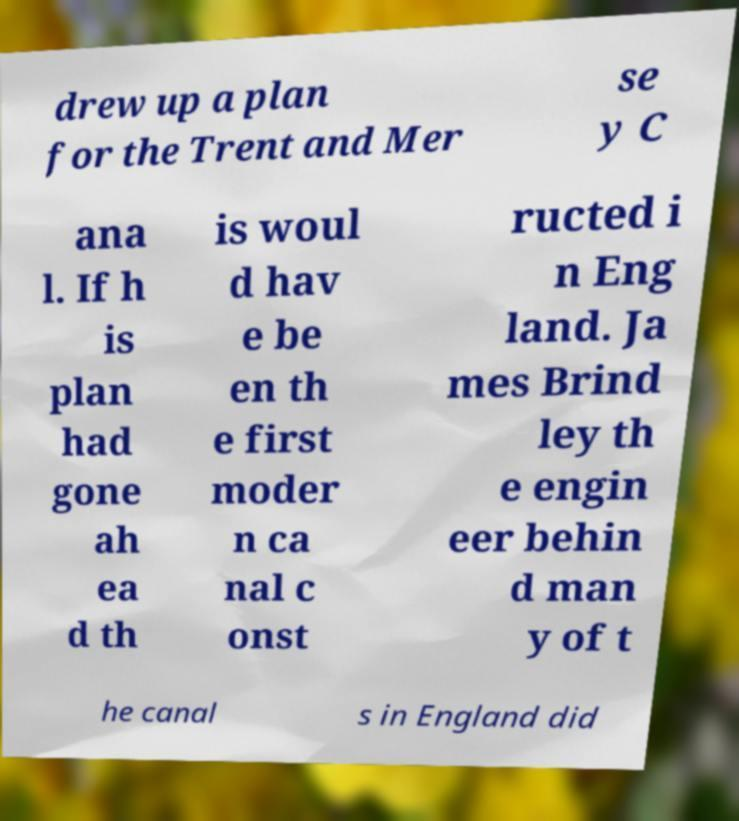Could you extract and type out the text from this image? drew up a plan for the Trent and Mer se y C ana l. If h is plan had gone ah ea d th is woul d hav e be en th e first moder n ca nal c onst ructed i n Eng land. Ja mes Brind ley th e engin eer behin d man y of t he canal s in England did 